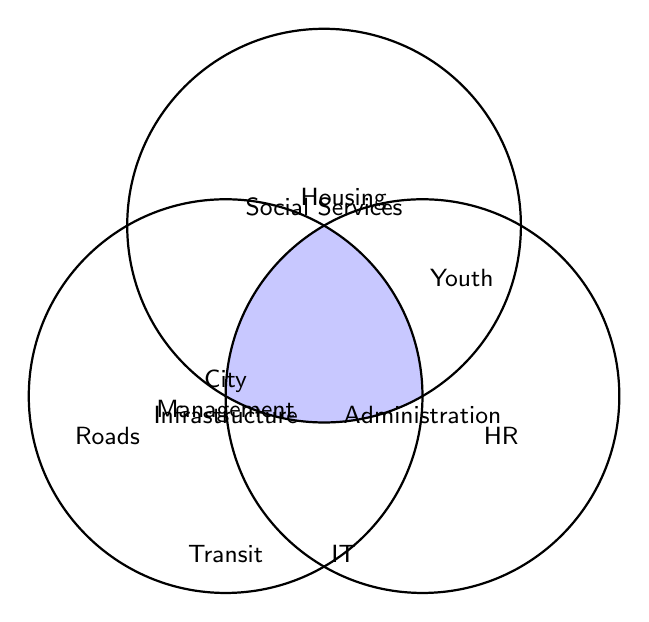What are the three main categories shown in the Venn Diagram? The three main categories shown in the Venn Diagram are the overlapping circles labeled ‘Infrastructure’, ‘Social Services’, and ‘Administration’. The titles are located within each respective circle.
Answer: Infrastructure, Social Services, Administration Which category does 'Roads' belong to? Locate the term 'Roads' within the Venn Diagram. It is positioned in the 'Infrastructure' circle.
Answer: Infrastructure Where is 'City Management' positioned in the Venn Diagram? 'City Management' is located at the intersection of all three circles, indicating it belongs to all the categories: Infrastructure, Social Services, and Administration.
Answer: Intersection of all categories What categories overlap to include 'Youth'? 'Youth’ is placed where the 'Social Services' and 'Administration' circles overlap. Therefore, it belongs to both categories.
Answer: Social Services and Administration Name one element that belongs exclusively to the ‘Social Services’ category? To determine the elements exclusive to 'Social Services', find the terms placed inside its circle but outside the overlapping areas with the other circles. 'Housing' is one such term.
Answer: Housing Which category does 'Transit' fall under? 'Transit' is located fully within the ‘Infrastructure’ circle, indicating it belongs to the 'Infrastructure' category.
Answer: Infrastructure Which elements are part of both 'Infrastructure' and 'Administration' but not 'Social Services'? The shared area between 'Infrastructure' and 'Administration' that's outside 'Social Services' must be identified. Review the visual intersections to find elements exclusively shared between these two circles.
Answer: There are none Which category exclusively contains the most elements? Count the elements exclusive to each circle: Infrastructure, Social Services, and Administration. Whichever category has the highest count has the most exclusive elements.
Answer: Administration Identify any elements that are part of all three categories. Check the center intersection of the three circles to find any terms that overlap in 'Infrastructure', 'Social Services', and 'Administration'. 'City Management' is located here.
Answer: City Management 